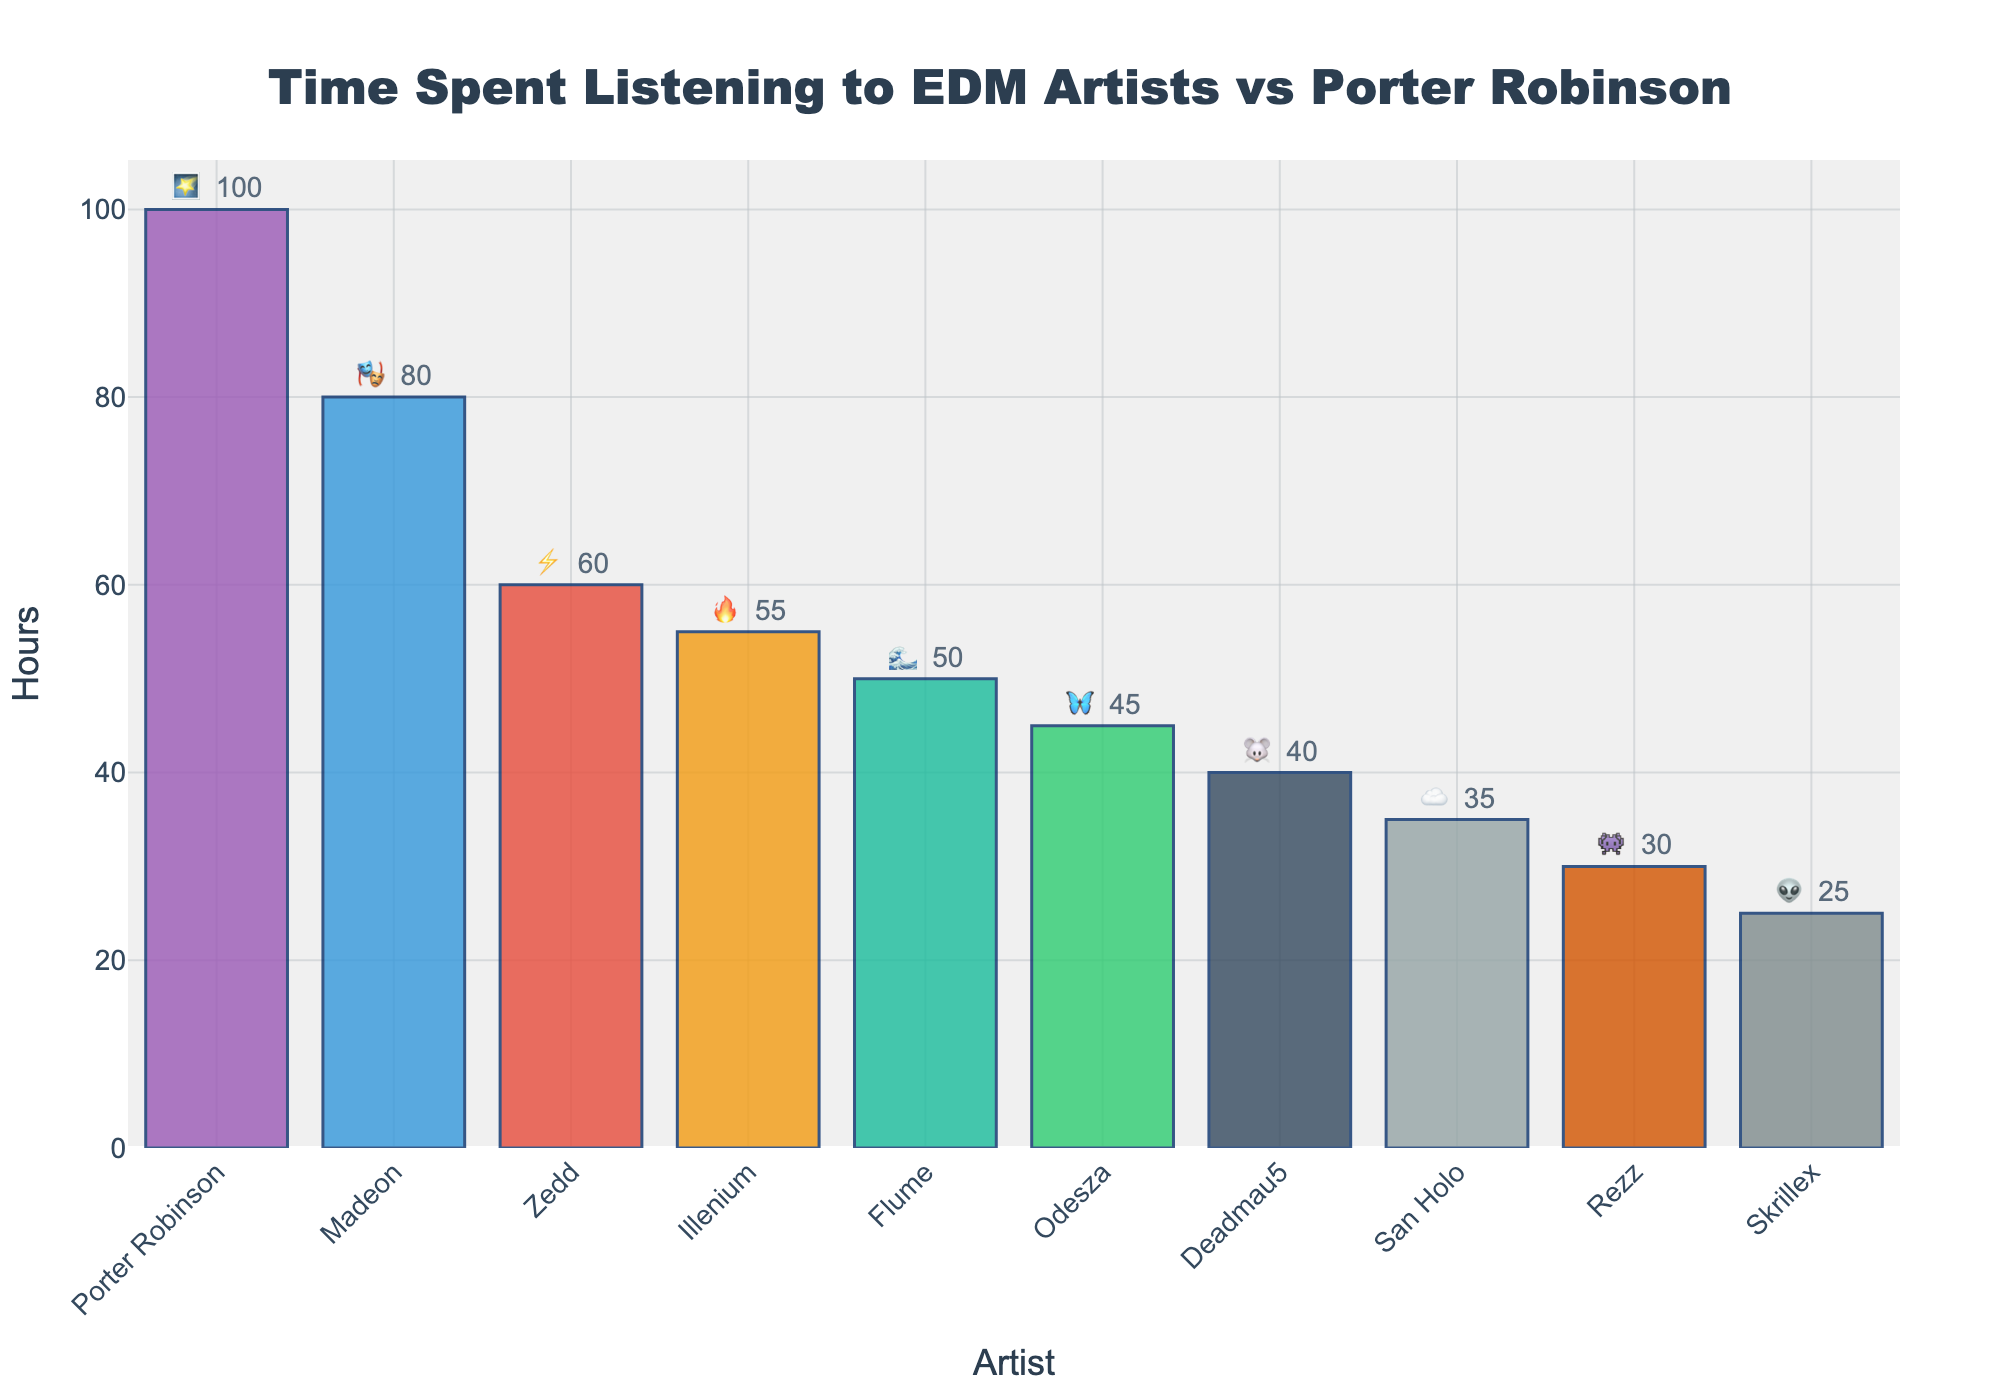What's the title of the chart? The title is located at the top of the chart. It provides a summary of what the visualization is about. The title is "Time Spent Listening to EDM Artists vs Porter Robinson".
Answer: "Time Spent Listening to EDM Artists vs Porter Robinson" Which artist has the maximum listening hours and what are those hours? The tallest bar in the plot indicates the artist with the maximum listening hours. Porter Robinson's bar is the tallest, representing 100 hours.
Answer: Porter Robinson, 100 hours What are the emojis for Flume and San Holo? Flume and San Holo have specific emojis next to their names in the bar chart. Flume's emoji is 🌊, and San Holo's emoji is ☁️.
Answer: Flume: 🌊, San Holo: ☁️ How many hours have been spent listening to Illenium and Rezz combined? Sum the hours from Illenium and Rezz's bars. Illenium has 55 hours and Rezz has 30 hours. Adding these together gives 85 hours.
Answer: 85 hours Who has more listening hours: Odesza or Deadmau5, and by how much? Compare the heights of Odesza's and Deadmau5's bars. Odesza has 45 hours, while Deadmau5 has 40 hours. Odesza has 5 more hours than Deadmau5.
Answer: Odesza, 5 hours more What's the average time spent listening to Skrillex, Madeon, and Deadmau5? Calculate the average by summing the hours of Skrillex (25), Madeon (80), and Deadmau5 (40) and dividing by 3. (25 + 80 + 40)/3 = 145/3 ≈ 48.33
Answer: ≈ 48.33 hours Which artist has the least listening hours and how many hours are those? The shortest bar in the plot indicates the artist with the least listening hours. Skrillex's bar is the shortest, representing 25 hours.
Answer: Skrillex, 25 hours What is the total time spent listening to all artists? Sum the hours of all artists listed in the chart: 100 + 80 + 60 + 55 + 50 + 45 + 40 + 35 + 30 + 25 = 520 hours.
Answer: 520 hours How many artists have fewer than 50 listening hours? Count the number of bars representing fewer than 50 hours. The artists are Odesza (45), Deadmau5 (40), San Holo (35), Rezz (30), and Skrillex (25). This totals 5 artists.
Answer: 5 artists 